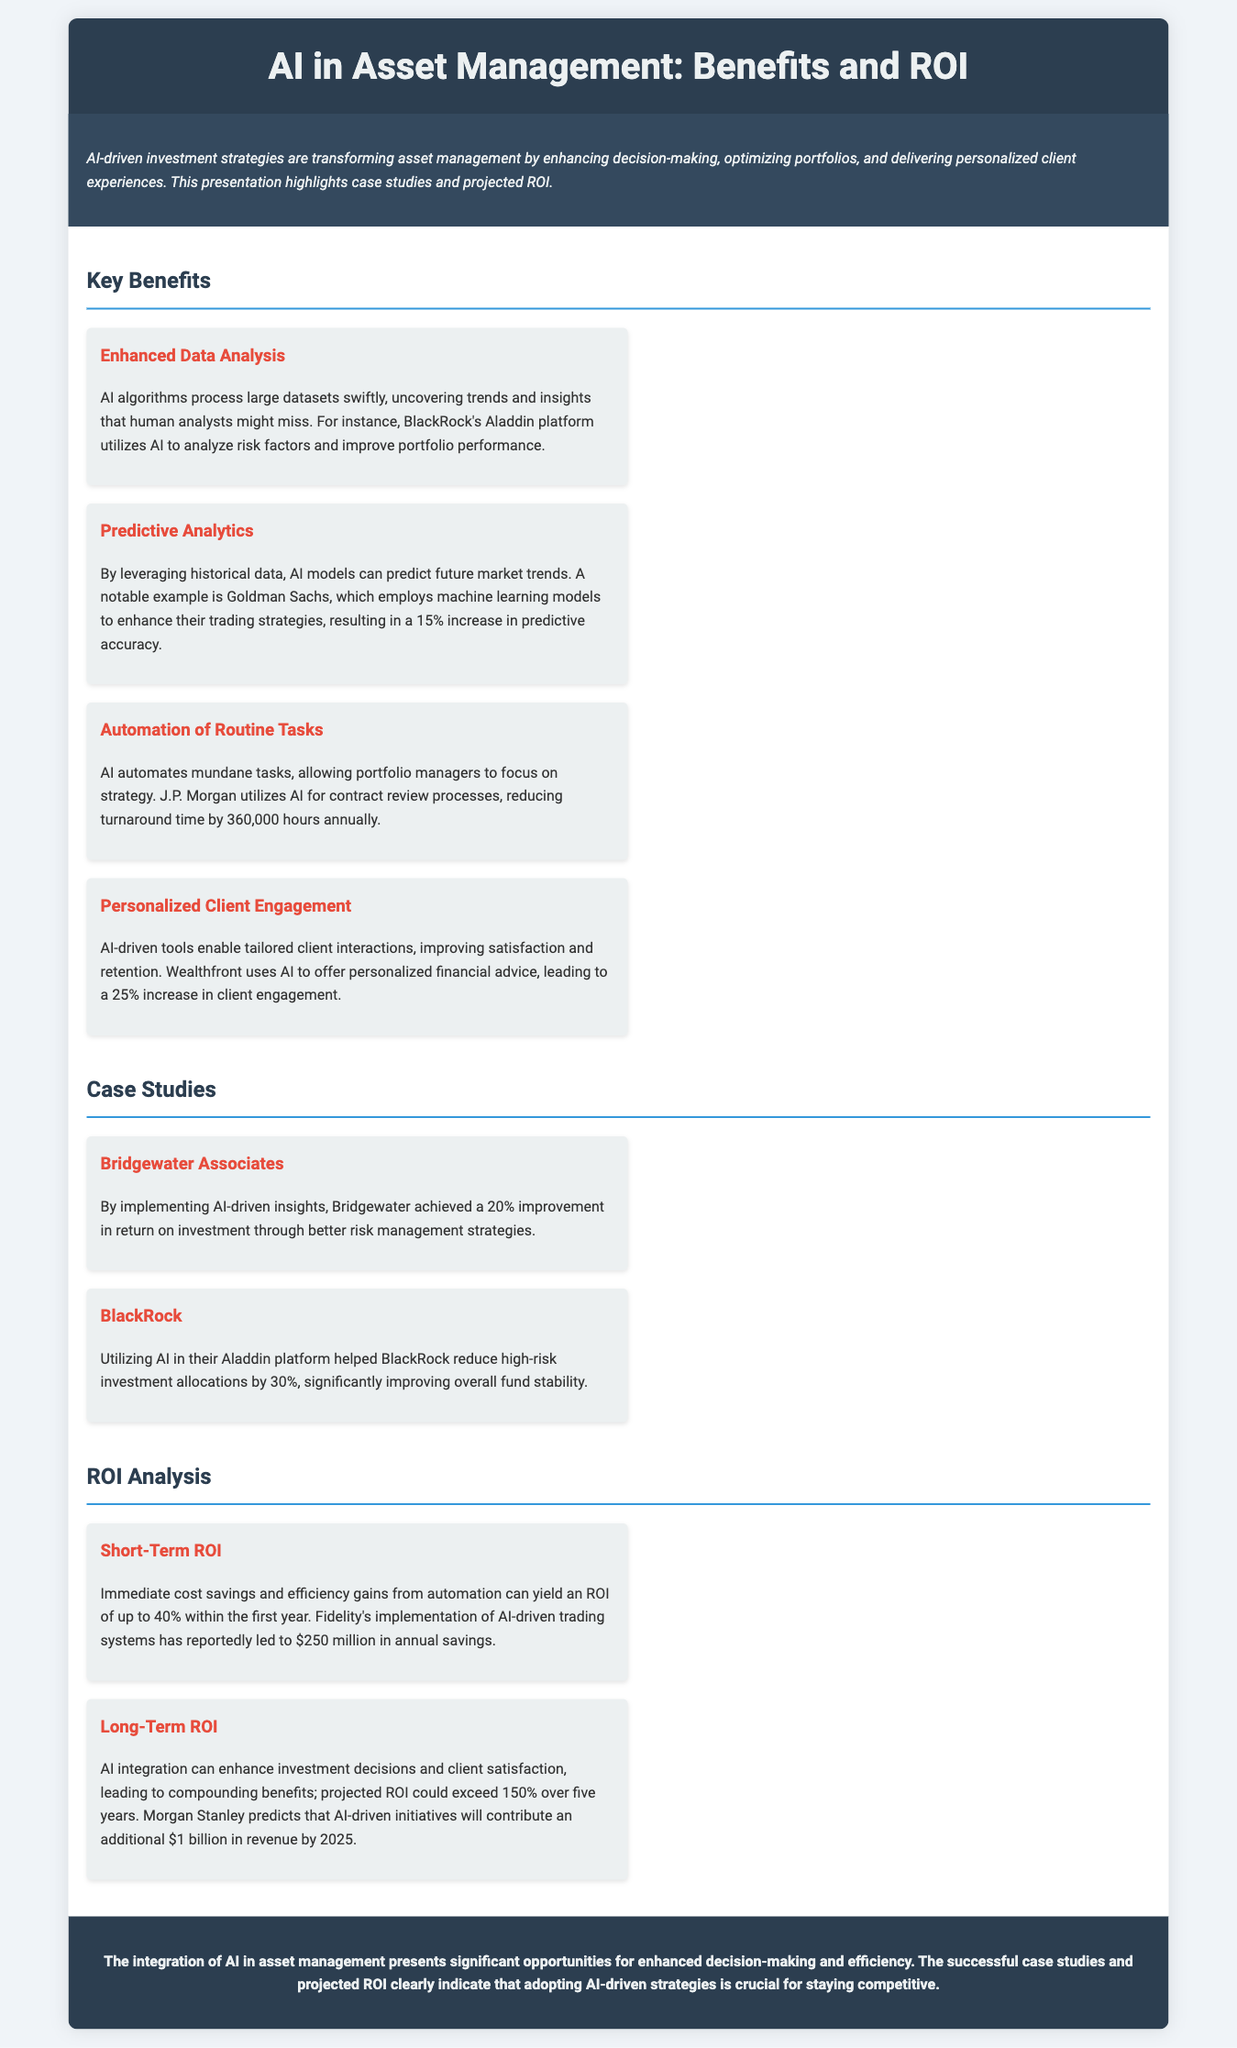What is the main focus of the presentation? The presentation highlights case studies and projected ROI regarding AI-driven investment strategies in asset management.
Answer: AI-driven investment strategies Which firm utilizes AI to analyze risk factors through their platform? The document states that BlackRock's Aladdin platform utilizes AI for this purpose.
Answer: BlackRock What is the projected short-term ROI from automation? The document indicates that ROI from automation could yield up to 40% within the first year.
Answer: 40% How much annual savings has Fidelity reportedly achieved from AI-driven trading systems? Fidelity's AI-driven trading systems reportedly led to $250 million in annual savings.
Answer: $250 million What percentage increase in predictive accuracy did Goldman Sachs achieve? The document mentions a 15% increase in predictive accuracy from machine learning models at Goldman Sachs.
Answer: 15% How much improvement in return on investment did Bridgewater Associates achieve with AI? Bridgewater achieved a 20% improvement in return on investment through AI-driven insights.
Answer: 20% What is one of the key benefits of AI mentioned in the presentation? One benefit noted is Enhanced Data Analysis, which AI offers by processing large datasets swiftly.
Answer: Enhanced Data Analysis What impact did AI have on J.P. Morgan's contract review processes? AI reduced J.P. Morgan's turnaround time by 360,000 hours annually.
Answer: 360,000 hours 